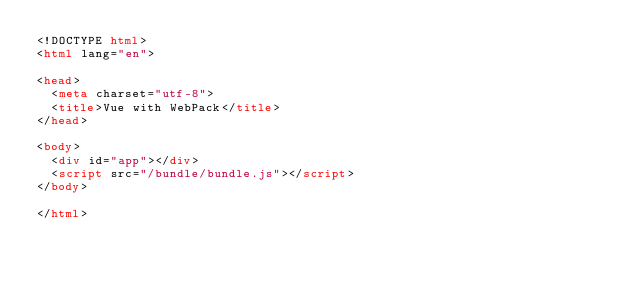Convert code to text. <code><loc_0><loc_0><loc_500><loc_500><_HTML_><!DOCTYPE html>
<html lang="en">

<head>
  <meta charset="utf-8">
  <title>Vue with WebPack</title>
</head>

<body>
  <div id="app"></div>
  <script src="/bundle/bundle.js"></script>
</body>

</html>
</code> 